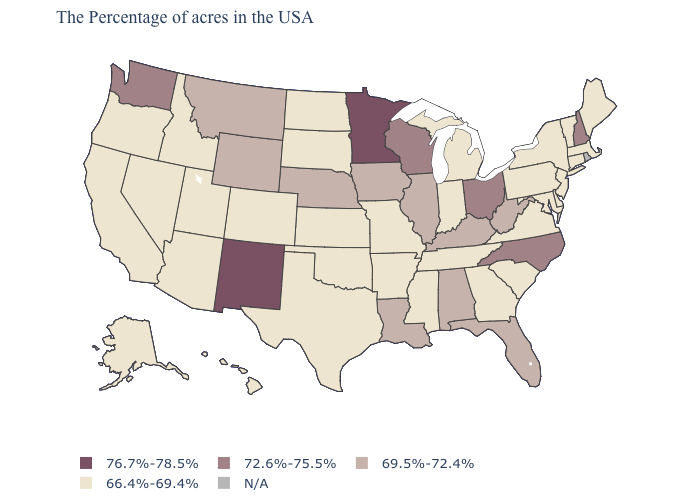Name the states that have a value in the range N/A?
Write a very short answer. Rhode Island. Name the states that have a value in the range 69.5%-72.4%?
Short answer required. West Virginia, Florida, Kentucky, Alabama, Illinois, Louisiana, Iowa, Nebraska, Wyoming, Montana. What is the value of Nevada?
Answer briefly. 66.4%-69.4%. Among the states that border Ohio , which have the lowest value?
Give a very brief answer. Pennsylvania, Michigan, Indiana. Is the legend a continuous bar?
Be succinct. No. Name the states that have a value in the range 72.6%-75.5%?
Keep it brief. New Hampshire, North Carolina, Ohio, Wisconsin, Washington. Which states have the lowest value in the USA?
Concise answer only. Maine, Massachusetts, Vermont, Connecticut, New York, New Jersey, Delaware, Maryland, Pennsylvania, Virginia, South Carolina, Georgia, Michigan, Indiana, Tennessee, Mississippi, Missouri, Arkansas, Kansas, Oklahoma, Texas, South Dakota, North Dakota, Colorado, Utah, Arizona, Idaho, Nevada, California, Oregon, Alaska, Hawaii. What is the value of Washington?
Quick response, please. 72.6%-75.5%. Which states have the lowest value in the USA?
Be succinct. Maine, Massachusetts, Vermont, Connecticut, New York, New Jersey, Delaware, Maryland, Pennsylvania, Virginia, South Carolina, Georgia, Michigan, Indiana, Tennessee, Mississippi, Missouri, Arkansas, Kansas, Oklahoma, Texas, South Dakota, North Dakota, Colorado, Utah, Arizona, Idaho, Nevada, California, Oregon, Alaska, Hawaii. Name the states that have a value in the range 69.5%-72.4%?
Quick response, please. West Virginia, Florida, Kentucky, Alabama, Illinois, Louisiana, Iowa, Nebraska, Wyoming, Montana. Name the states that have a value in the range N/A?
Write a very short answer. Rhode Island. Which states have the lowest value in the USA?
Quick response, please. Maine, Massachusetts, Vermont, Connecticut, New York, New Jersey, Delaware, Maryland, Pennsylvania, Virginia, South Carolina, Georgia, Michigan, Indiana, Tennessee, Mississippi, Missouri, Arkansas, Kansas, Oklahoma, Texas, South Dakota, North Dakota, Colorado, Utah, Arizona, Idaho, Nevada, California, Oregon, Alaska, Hawaii. What is the value of South Carolina?
Quick response, please. 66.4%-69.4%. 